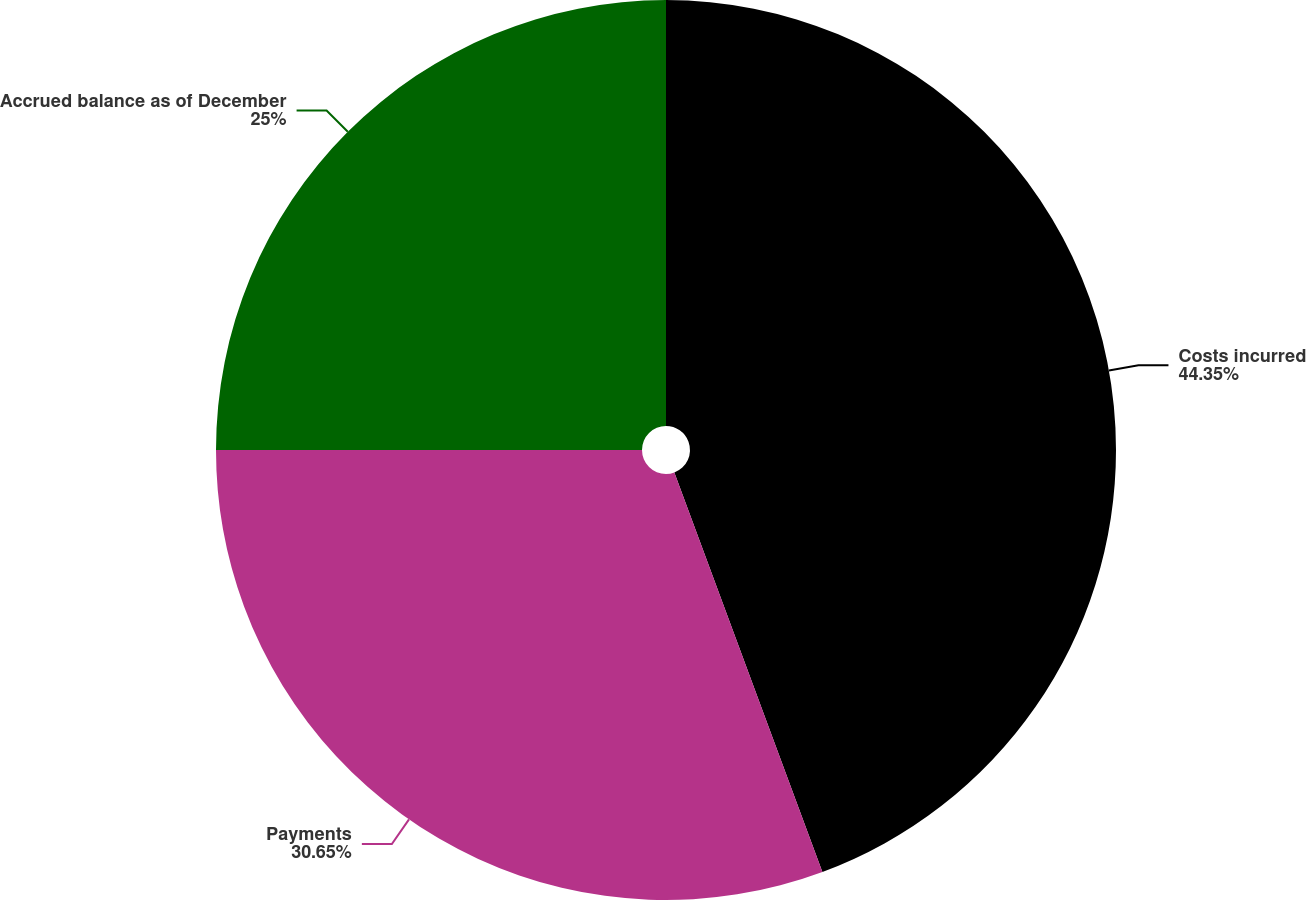<chart> <loc_0><loc_0><loc_500><loc_500><pie_chart><fcel>Costs incurred<fcel>Payments<fcel>Accrued balance as of December<nl><fcel>44.35%<fcel>30.65%<fcel>25.0%<nl></chart> 